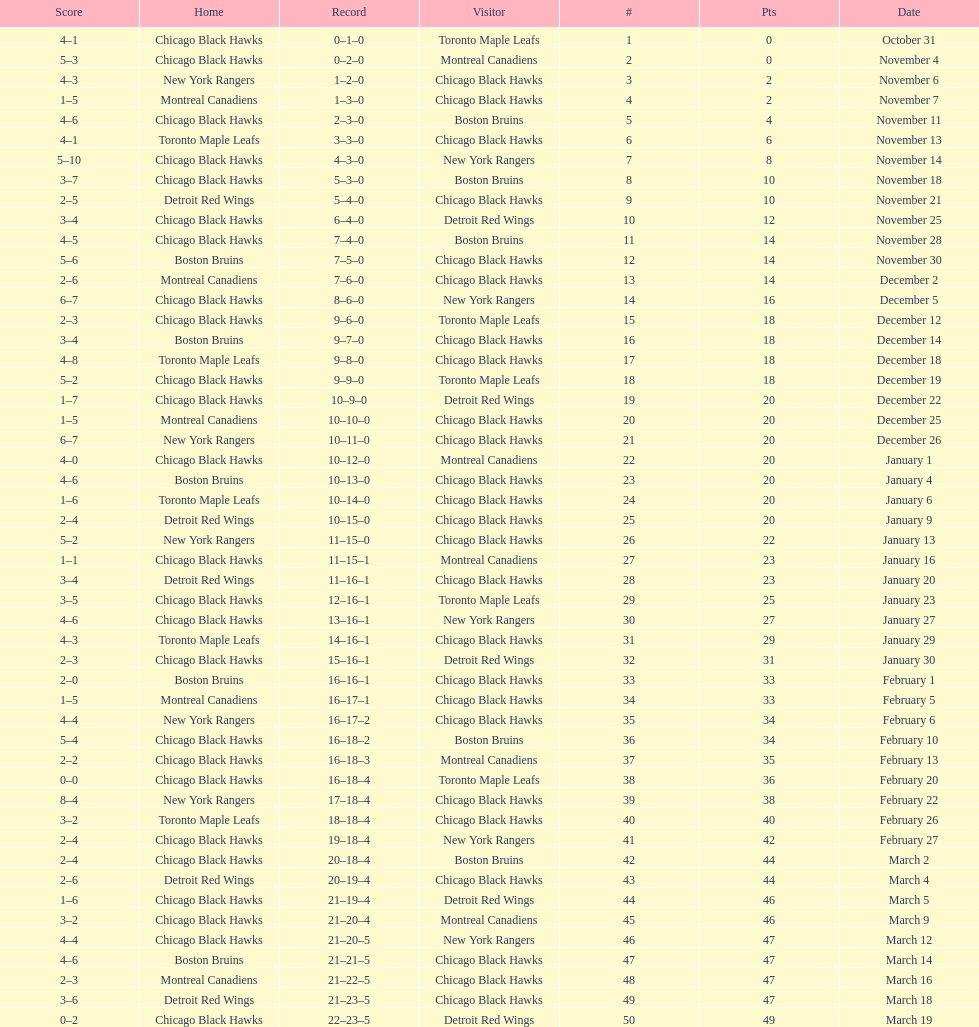How many total games did they win? 22. 